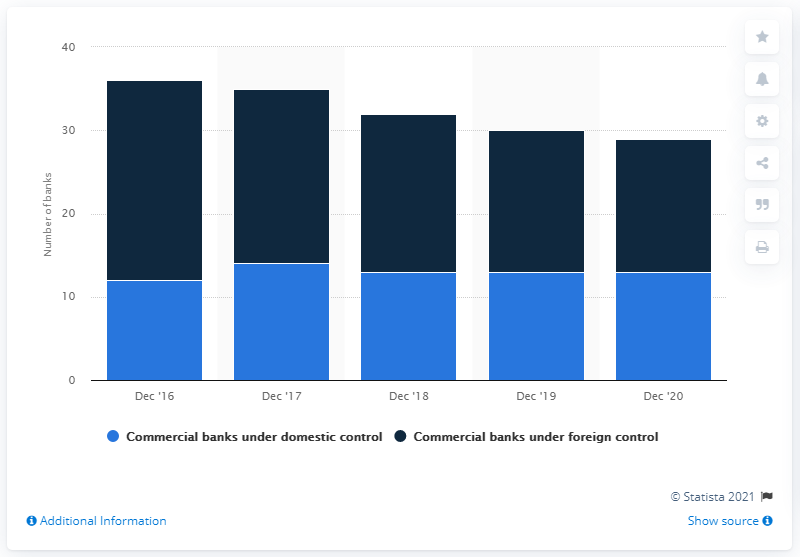Specify some key components in this picture. There were 13 commercial banks that were under domestic control in Poland in December of 2020. 